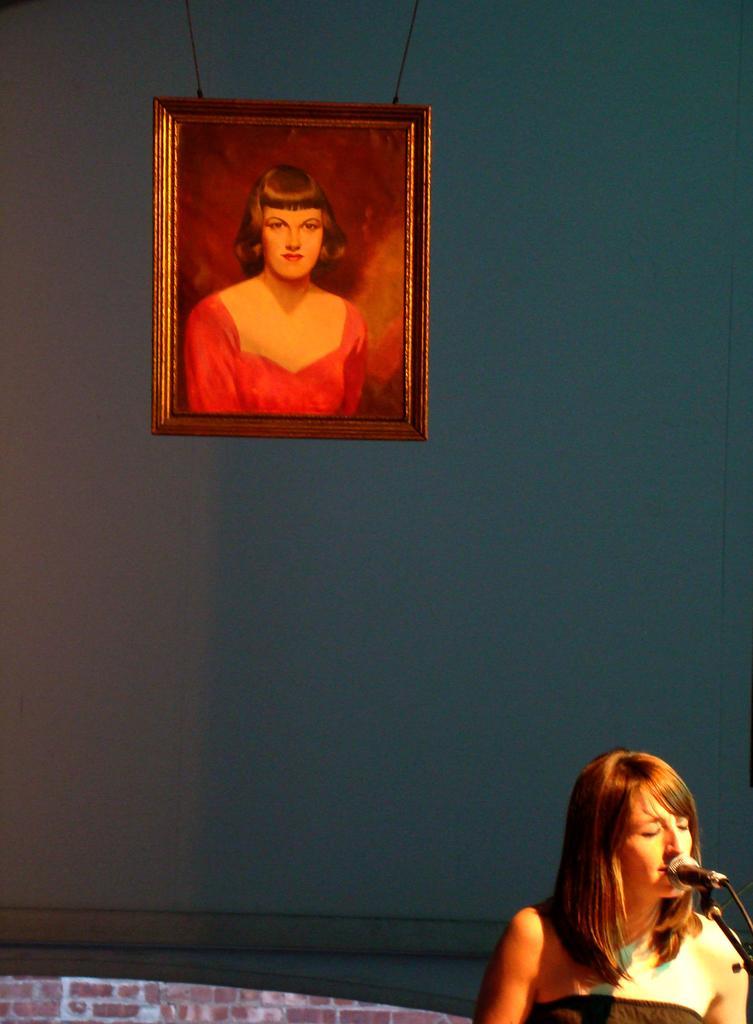Can you describe this image briefly? In the bottom right there is a woman. In front of her there is a mike stand. It seems like she's singing. At the back of her there is a wall. At the top of the image there is a photo frame attached to the wall. 